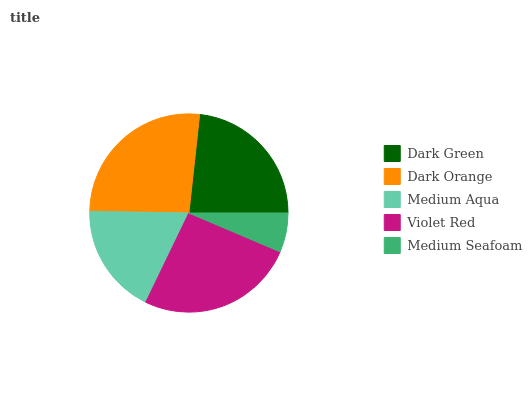Is Medium Seafoam the minimum?
Answer yes or no. Yes. Is Dark Orange the maximum?
Answer yes or no. Yes. Is Medium Aqua the minimum?
Answer yes or no. No. Is Medium Aqua the maximum?
Answer yes or no. No. Is Dark Orange greater than Medium Aqua?
Answer yes or no. Yes. Is Medium Aqua less than Dark Orange?
Answer yes or no. Yes. Is Medium Aqua greater than Dark Orange?
Answer yes or no. No. Is Dark Orange less than Medium Aqua?
Answer yes or no. No. Is Dark Green the high median?
Answer yes or no. Yes. Is Dark Green the low median?
Answer yes or no. Yes. Is Medium Aqua the high median?
Answer yes or no. No. Is Dark Orange the low median?
Answer yes or no. No. 